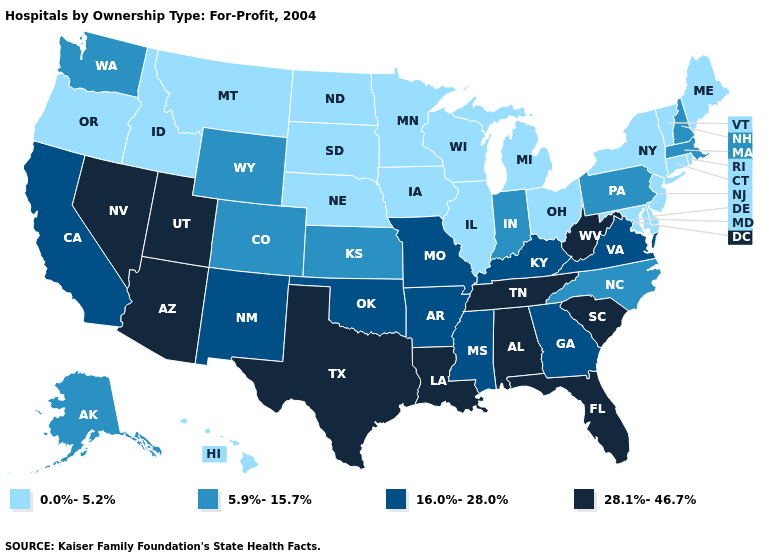What is the value of Delaware?
Answer briefly. 0.0%-5.2%. Name the states that have a value in the range 0.0%-5.2%?
Answer briefly. Connecticut, Delaware, Hawaii, Idaho, Illinois, Iowa, Maine, Maryland, Michigan, Minnesota, Montana, Nebraska, New Jersey, New York, North Dakota, Ohio, Oregon, Rhode Island, South Dakota, Vermont, Wisconsin. Is the legend a continuous bar?
Quick response, please. No. What is the value of Montana?
Keep it brief. 0.0%-5.2%. What is the value of New Hampshire?
Quick response, please. 5.9%-15.7%. Does the map have missing data?
Quick response, please. No. What is the highest value in the West ?
Give a very brief answer. 28.1%-46.7%. Does Oklahoma have the same value as Alabama?
Short answer required. No. Which states have the lowest value in the USA?
Short answer required. Connecticut, Delaware, Hawaii, Idaho, Illinois, Iowa, Maine, Maryland, Michigan, Minnesota, Montana, Nebraska, New Jersey, New York, North Dakota, Ohio, Oregon, Rhode Island, South Dakota, Vermont, Wisconsin. Name the states that have a value in the range 5.9%-15.7%?
Quick response, please. Alaska, Colorado, Indiana, Kansas, Massachusetts, New Hampshire, North Carolina, Pennsylvania, Washington, Wyoming. Does Texas have the lowest value in the South?
Answer briefly. No. Among the states that border Nebraska , does Colorado have the highest value?
Answer briefly. No. What is the value of Mississippi?
Answer briefly. 16.0%-28.0%. Which states have the lowest value in the USA?
Keep it brief. Connecticut, Delaware, Hawaii, Idaho, Illinois, Iowa, Maine, Maryland, Michigan, Minnesota, Montana, Nebraska, New Jersey, New York, North Dakota, Ohio, Oregon, Rhode Island, South Dakota, Vermont, Wisconsin. 